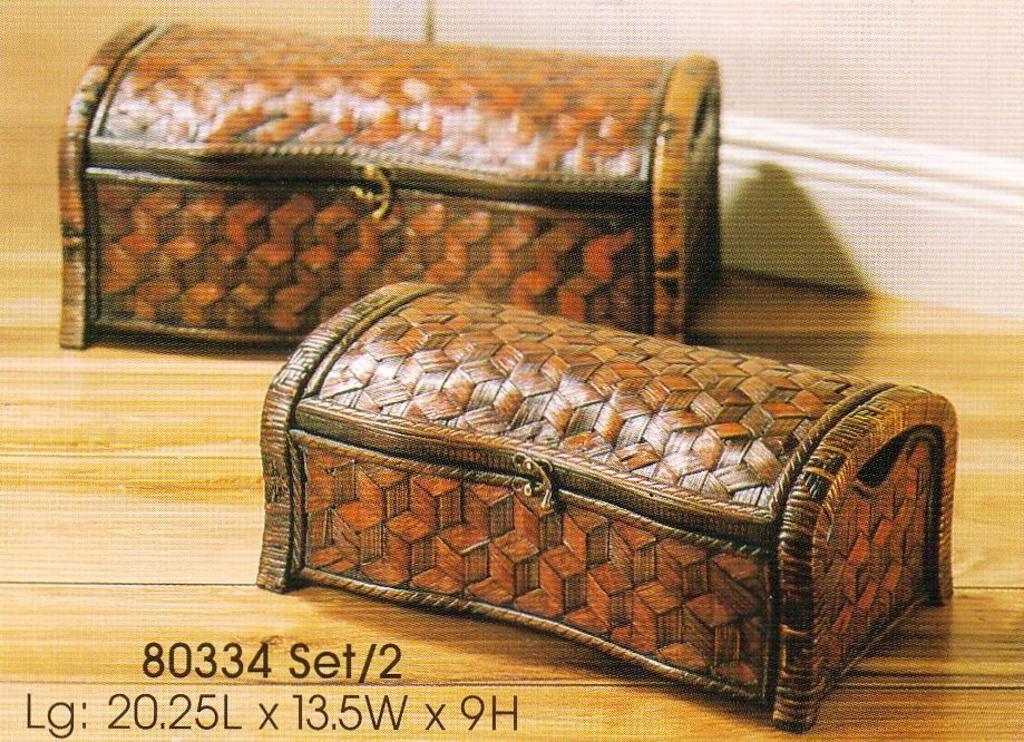What type of objects are on the wooden floor in the image? There are small boxes on the wooden floor in the image. Can you describe any architectural features in the image? Yes, there is a door visible in the image. Where are the numbers and alphabets located in the image? The numbers and alphabets are present in the bottom left corner of the image. What type of animals can be seen in the zoo in the image? There is no zoo present in the image; it features small boxes on a wooden floor and a door. What type of vehicle is the coach in the image? There is no coach present in the image. 